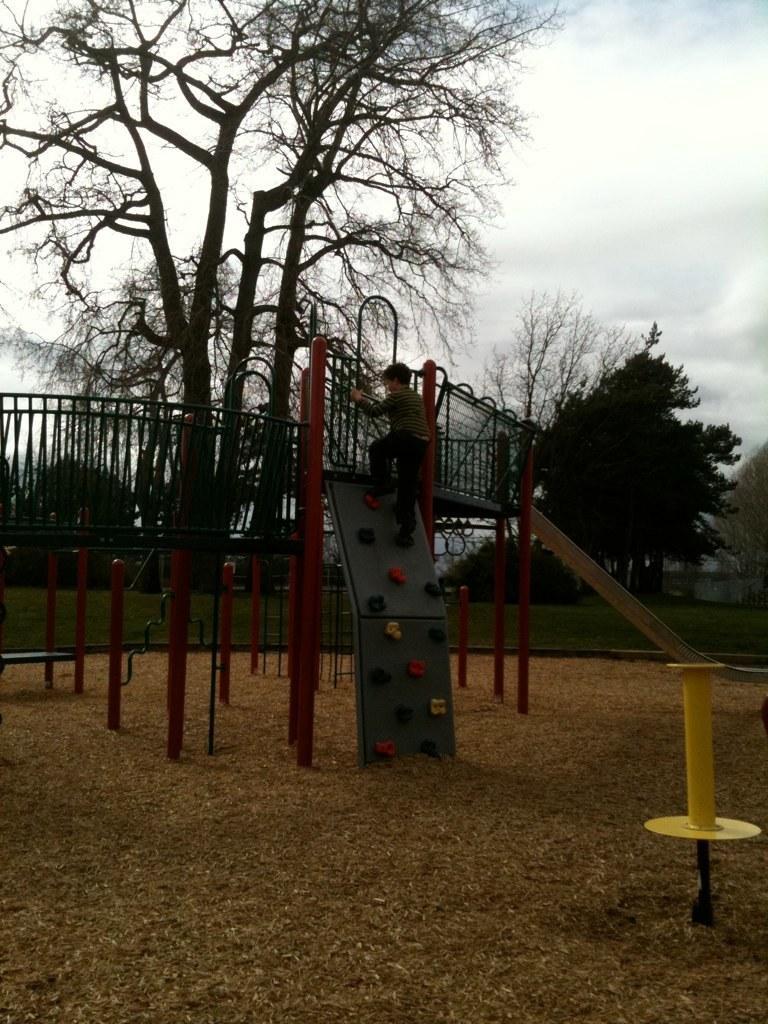Could you give a brief overview of what you see in this image? In this image I can see grille, rods, boy, trees, grass, cloudy sky and objects. 